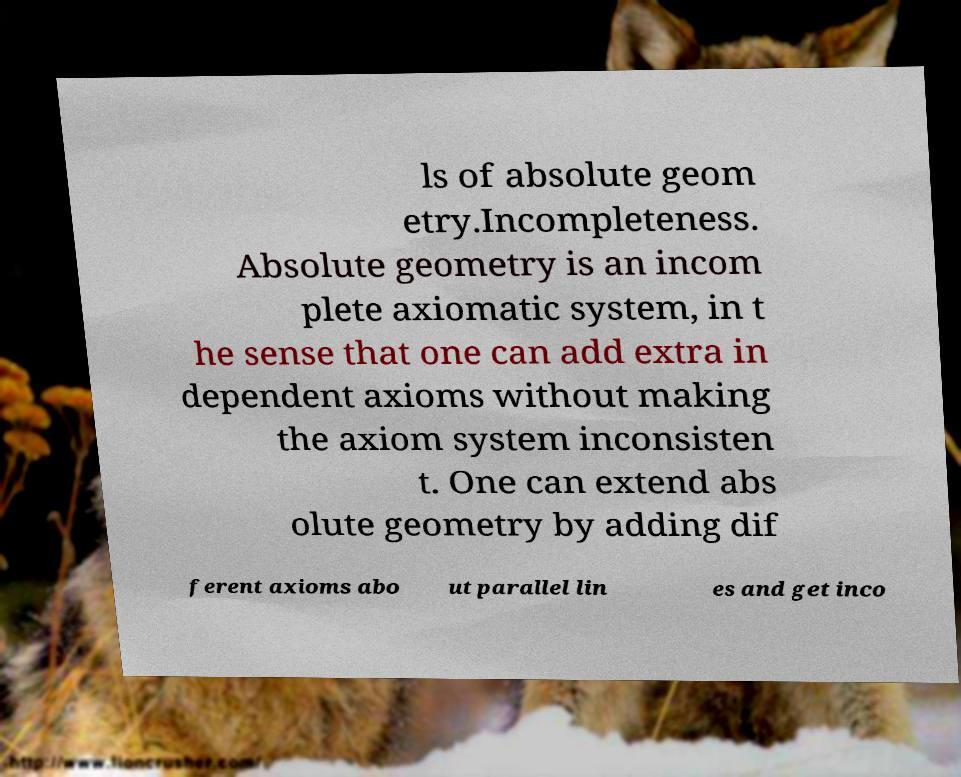Could you assist in decoding the text presented in this image and type it out clearly? ls of absolute geom etry.Incompleteness. Absolute geometry is an incom plete axiomatic system, in t he sense that one can add extra in dependent axioms without making the axiom system inconsisten t. One can extend abs olute geometry by adding dif ferent axioms abo ut parallel lin es and get inco 